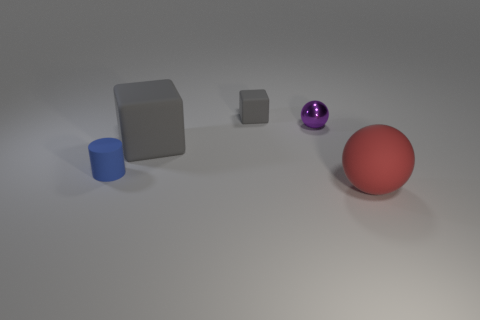What is the material of the purple object that is behind the large matte object to the left of the red matte object?
Ensure brevity in your answer.  Metal. Is the size of the blue matte thing the same as the purple ball?
Your response must be concise. Yes. How many objects are objects that are in front of the large rubber block or small red cubes?
Ensure brevity in your answer.  2. There is a big object that is left of the large thing that is in front of the tiny blue object; what shape is it?
Offer a very short reply. Cube. Do the matte cylinder and the matte block behind the tiny purple object have the same size?
Your response must be concise. Yes. What is the block behind the large gray object made of?
Make the answer very short. Rubber. How many matte objects are right of the blue thing and to the left of the tiny matte cube?
Your response must be concise. 1. There is a blue object that is the same size as the shiny sphere; what is its material?
Ensure brevity in your answer.  Rubber. Do the ball that is in front of the tiny blue matte cylinder and the gray rubber object in front of the purple ball have the same size?
Make the answer very short. Yes. There is a big rubber sphere; are there any big matte things behind it?
Your response must be concise. Yes. 